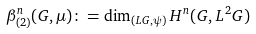Convert formula to latex. <formula><loc_0><loc_0><loc_500><loc_500>\beta ^ { n } _ { ( 2 ) } ( G , \mu ) \colon = \dim _ { ( L G , \psi ) } H ^ { n } ( G , L ^ { 2 } G )</formula> 